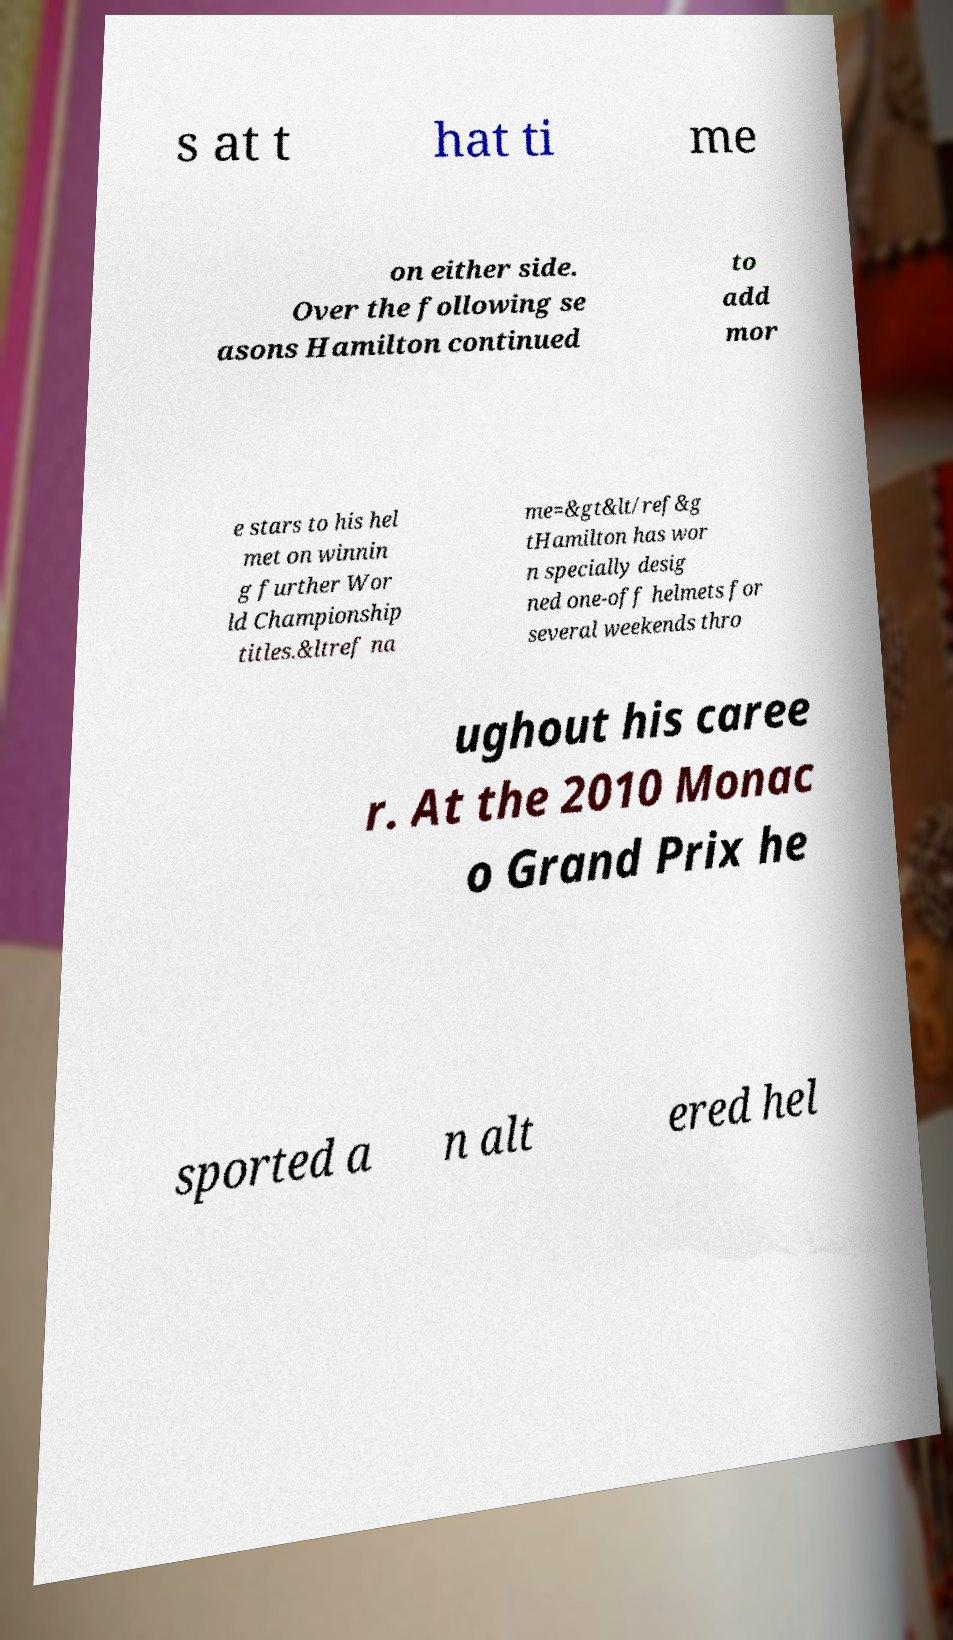There's text embedded in this image that I need extracted. Can you transcribe it verbatim? s at t hat ti me on either side. Over the following se asons Hamilton continued to add mor e stars to his hel met on winnin g further Wor ld Championship titles.&ltref na me=&gt&lt/ref&g tHamilton has wor n specially desig ned one-off helmets for several weekends thro ughout his caree r. At the 2010 Monac o Grand Prix he sported a n alt ered hel 